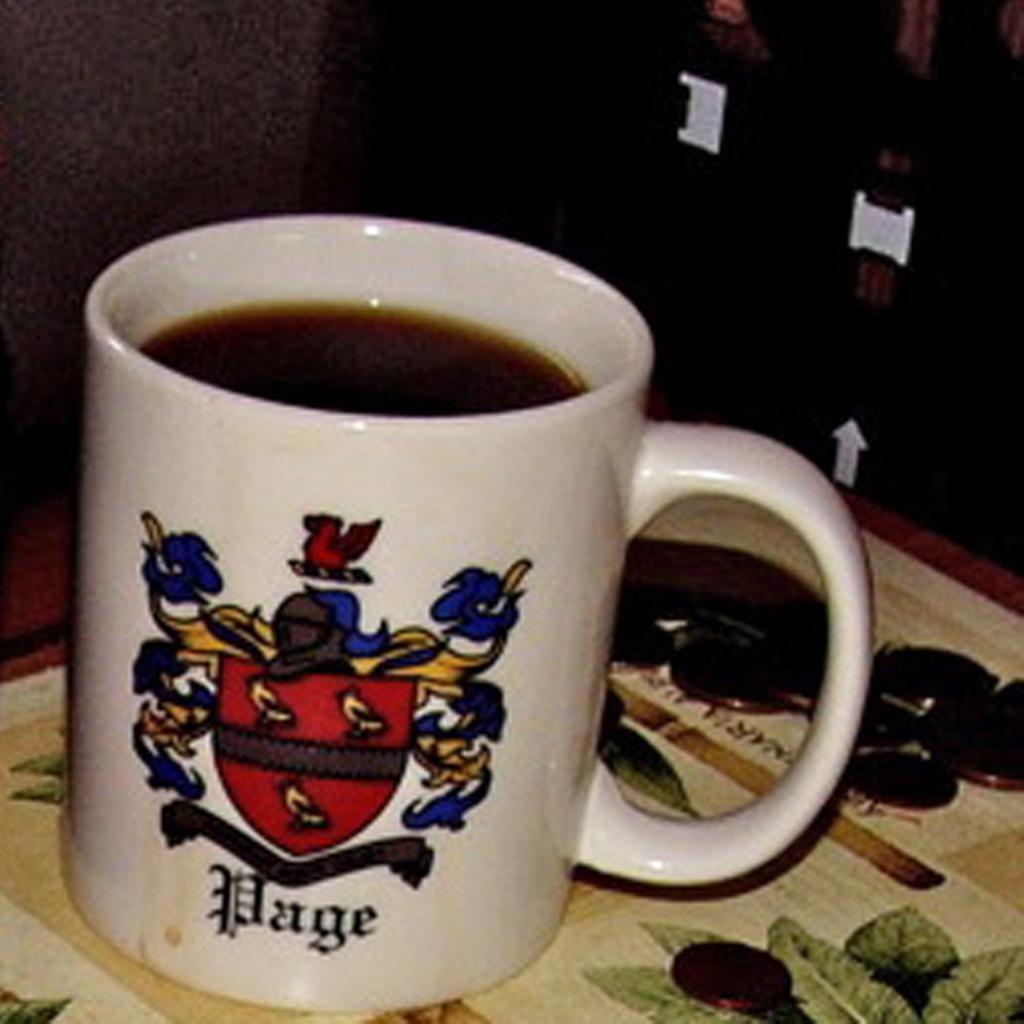What does the cup say?
Keep it short and to the point. Page. What is the surname of the coat of arms on the mug?
Your answer should be very brief. Page. 